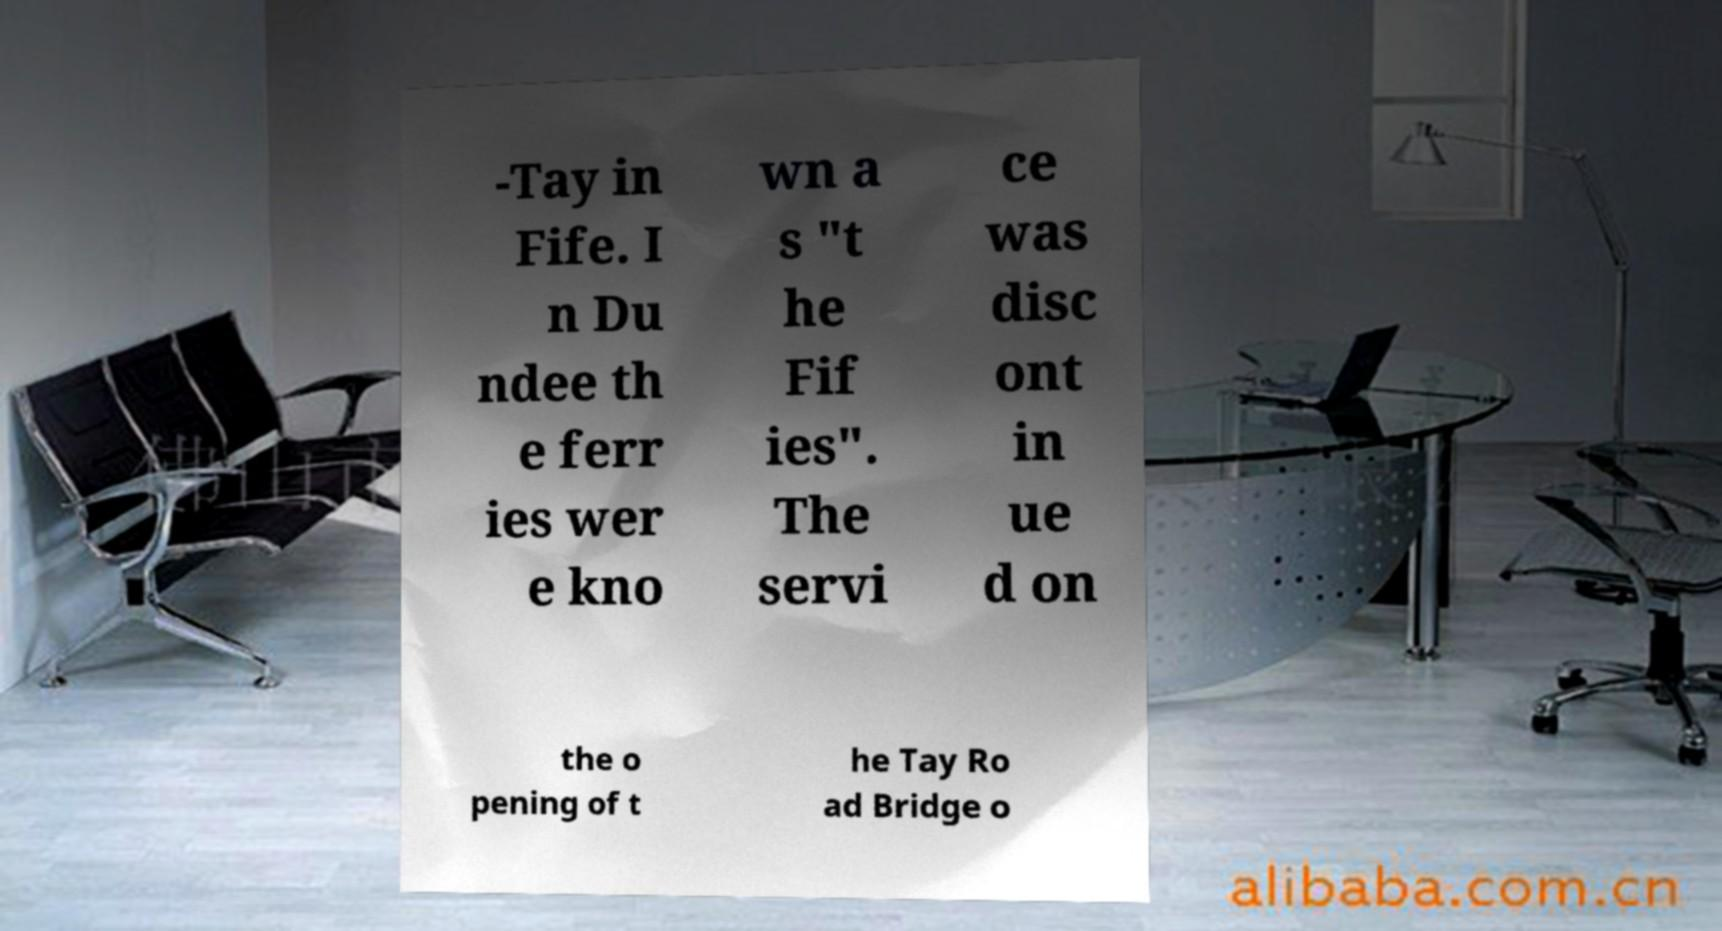For documentation purposes, I need the text within this image transcribed. Could you provide that? -Tay in Fife. I n Du ndee th e ferr ies wer e kno wn a s "t he Fif ies". The servi ce was disc ont in ue d on the o pening of t he Tay Ro ad Bridge o 